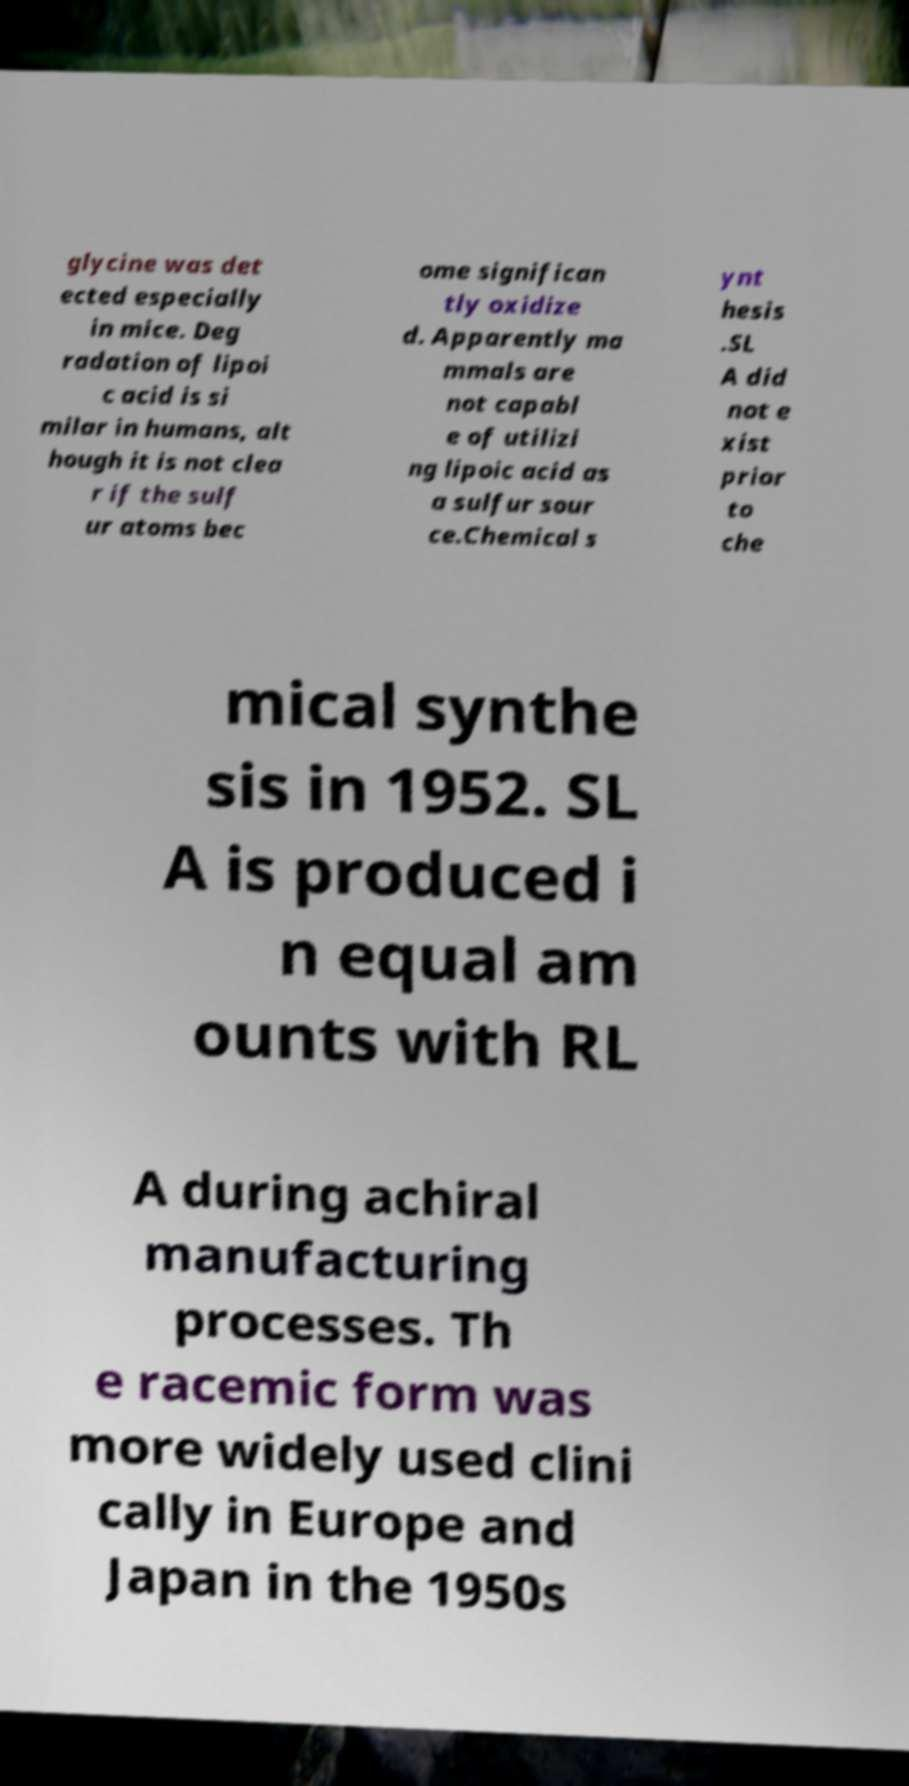Could you extract and type out the text from this image? glycine was det ected especially in mice. Deg radation of lipoi c acid is si milar in humans, alt hough it is not clea r if the sulf ur atoms bec ome significan tly oxidize d. Apparently ma mmals are not capabl e of utilizi ng lipoic acid as a sulfur sour ce.Chemical s ynt hesis .SL A did not e xist prior to che mical synthe sis in 1952. SL A is produced i n equal am ounts with RL A during achiral manufacturing processes. Th e racemic form was more widely used clini cally in Europe and Japan in the 1950s 